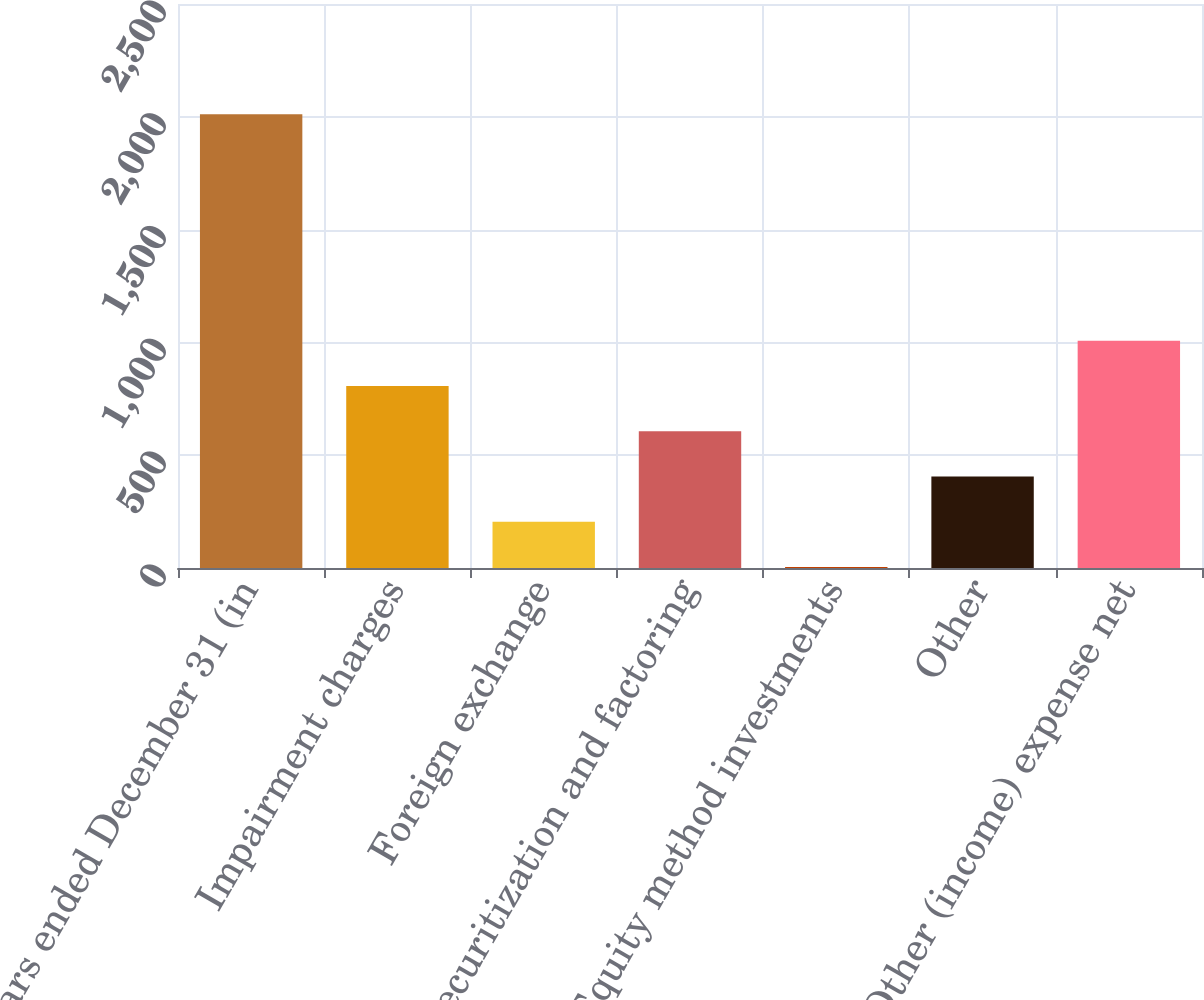Convert chart. <chart><loc_0><loc_0><loc_500><loc_500><bar_chart><fcel>years ended December 31 (in<fcel>Impairment charges<fcel>Foreign exchange<fcel>Securitization and factoring<fcel>Equity method investments<fcel>Other<fcel>Other (income) expense net<nl><fcel>2011<fcel>806.8<fcel>204.7<fcel>606.1<fcel>4<fcel>405.4<fcel>1007.5<nl></chart> 